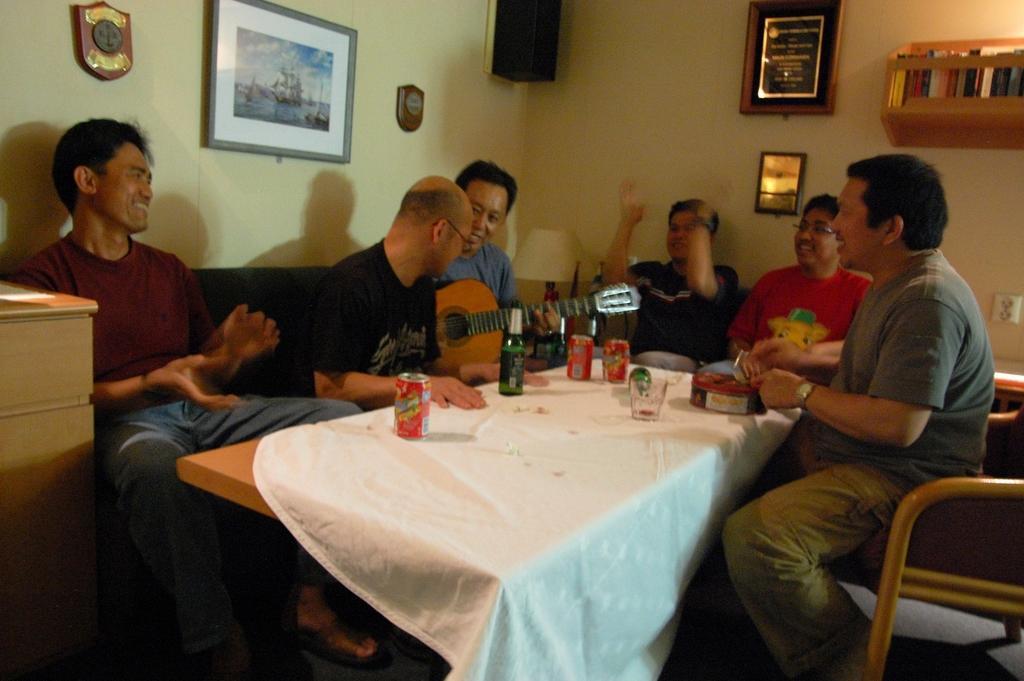Could you give a brief overview of what you see in this image? In this image we can see six men sitting on chairs in front of a table, there is a bottle and three tens and one empty glass on table, table is covered by a cloth, in the background we can see a wall and some portraits here. 